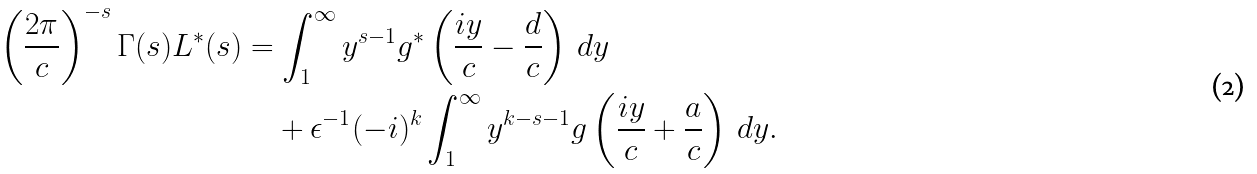Convert formula to latex. <formula><loc_0><loc_0><loc_500><loc_500>\left ( \frac { 2 \pi } c \right ) ^ { - s } \Gamma ( s ) L ^ { \ast } ( s ) & = \int ^ { \infty } _ { 1 } y ^ { s - 1 } g ^ { \ast } \left ( \frac { i y } c - \frac { d } { c } \right ) \, d y \\ & \quad + \epsilon ^ { - 1 } ( - i ) ^ { k } \int ^ { \infty } _ { 1 } y ^ { k - s - 1 } g \left ( \frac { i y } c + \frac { a } { c } \right ) \, d y .</formula> 